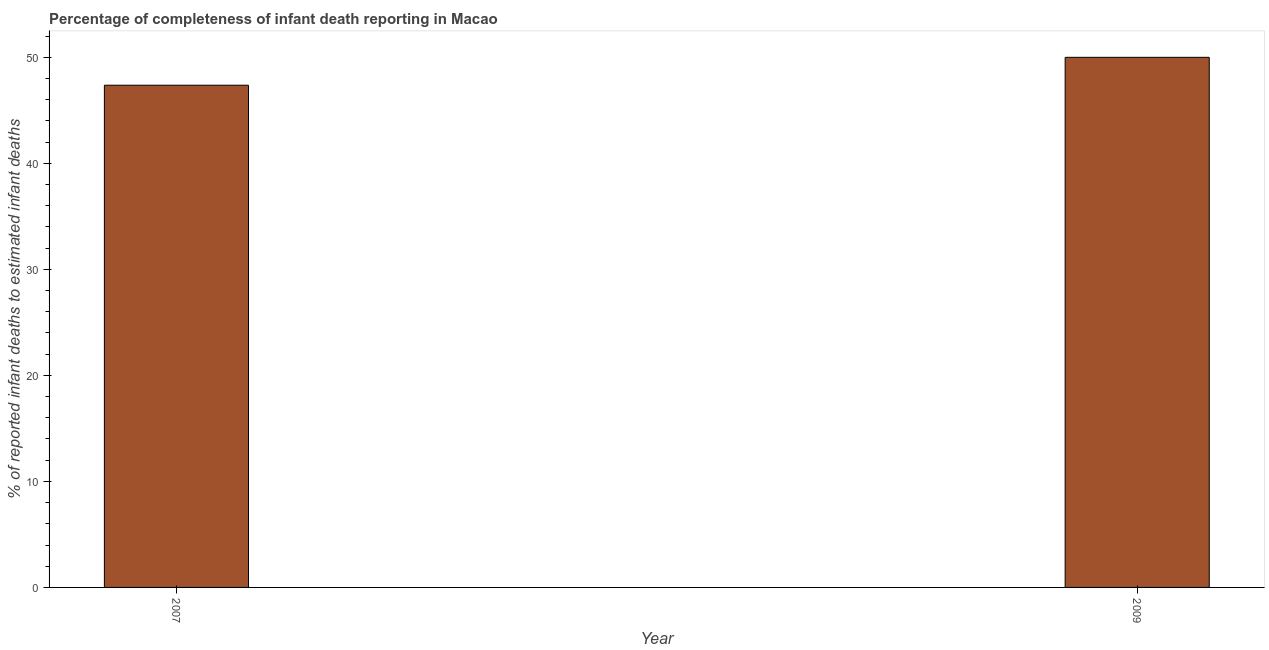Does the graph contain grids?
Make the answer very short. No. What is the title of the graph?
Offer a very short reply. Percentage of completeness of infant death reporting in Macao. What is the label or title of the Y-axis?
Provide a short and direct response. % of reported infant deaths to estimated infant deaths. What is the completeness of infant death reporting in 2007?
Provide a succinct answer. 47.37. Across all years, what is the maximum completeness of infant death reporting?
Provide a succinct answer. 50. Across all years, what is the minimum completeness of infant death reporting?
Make the answer very short. 47.37. In which year was the completeness of infant death reporting maximum?
Your answer should be very brief. 2009. What is the sum of the completeness of infant death reporting?
Your response must be concise. 97.37. What is the difference between the completeness of infant death reporting in 2007 and 2009?
Make the answer very short. -2.63. What is the average completeness of infant death reporting per year?
Your answer should be compact. 48.68. What is the median completeness of infant death reporting?
Your answer should be very brief. 48.68. What is the ratio of the completeness of infant death reporting in 2007 to that in 2009?
Offer a terse response. 0.95. In how many years, is the completeness of infant death reporting greater than the average completeness of infant death reporting taken over all years?
Give a very brief answer. 1. How many years are there in the graph?
Keep it short and to the point. 2. What is the difference between two consecutive major ticks on the Y-axis?
Provide a short and direct response. 10. Are the values on the major ticks of Y-axis written in scientific E-notation?
Give a very brief answer. No. What is the % of reported infant deaths to estimated infant deaths of 2007?
Give a very brief answer. 47.37. What is the % of reported infant deaths to estimated infant deaths of 2009?
Offer a terse response. 50. What is the difference between the % of reported infant deaths to estimated infant deaths in 2007 and 2009?
Offer a terse response. -2.63. What is the ratio of the % of reported infant deaths to estimated infant deaths in 2007 to that in 2009?
Give a very brief answer. 0.95. 